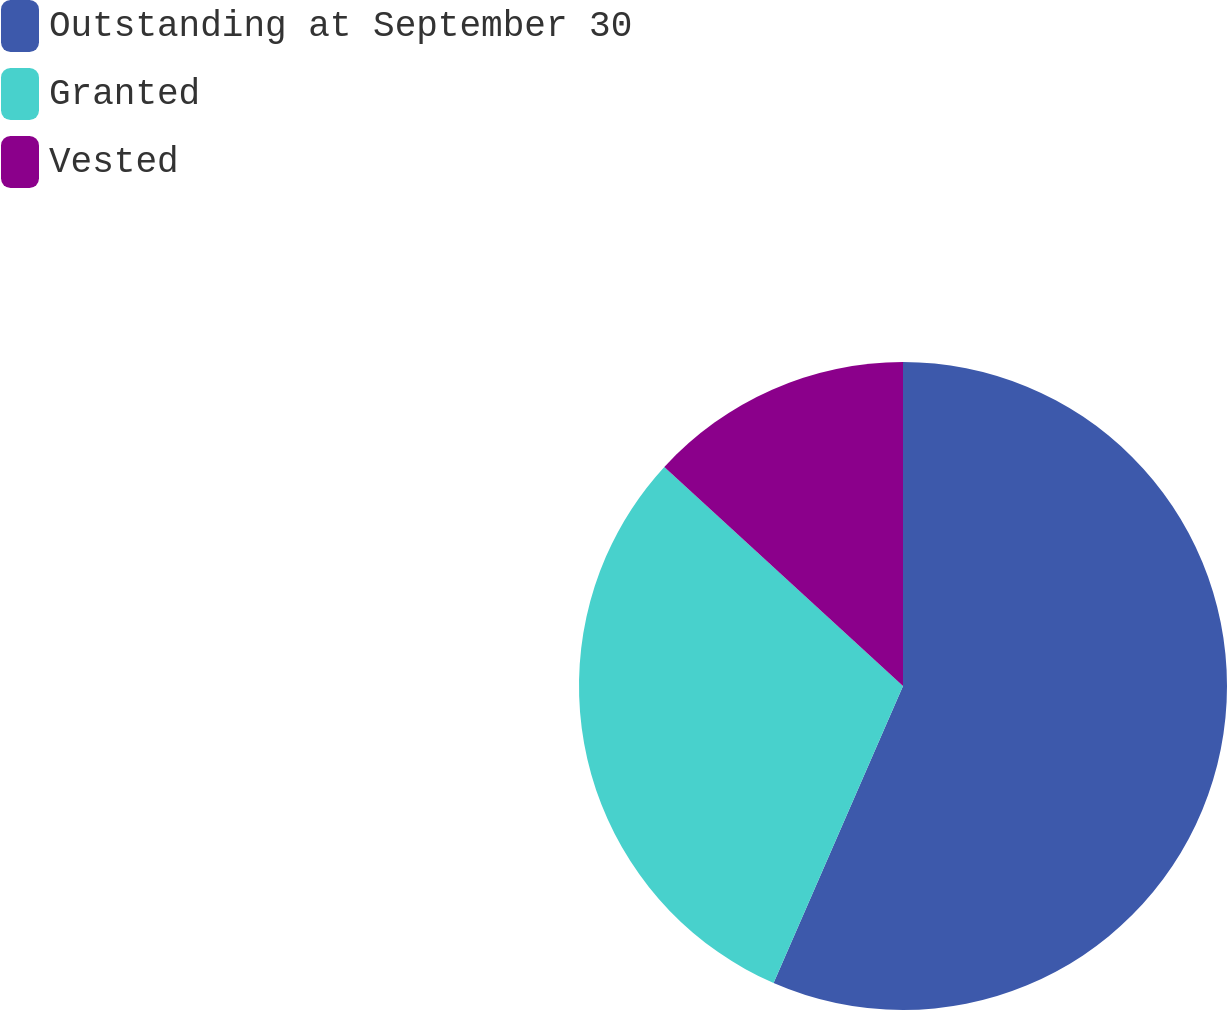<chart> <loc_0><loc_0><loc_500><loc_500><pie_chart><fcel>Outstanding at September 30<fcel>Granted<fcel>Vested<nl><fcel>56.54%<fcel>30.28%<fcel>13.18%<nl></chart> 